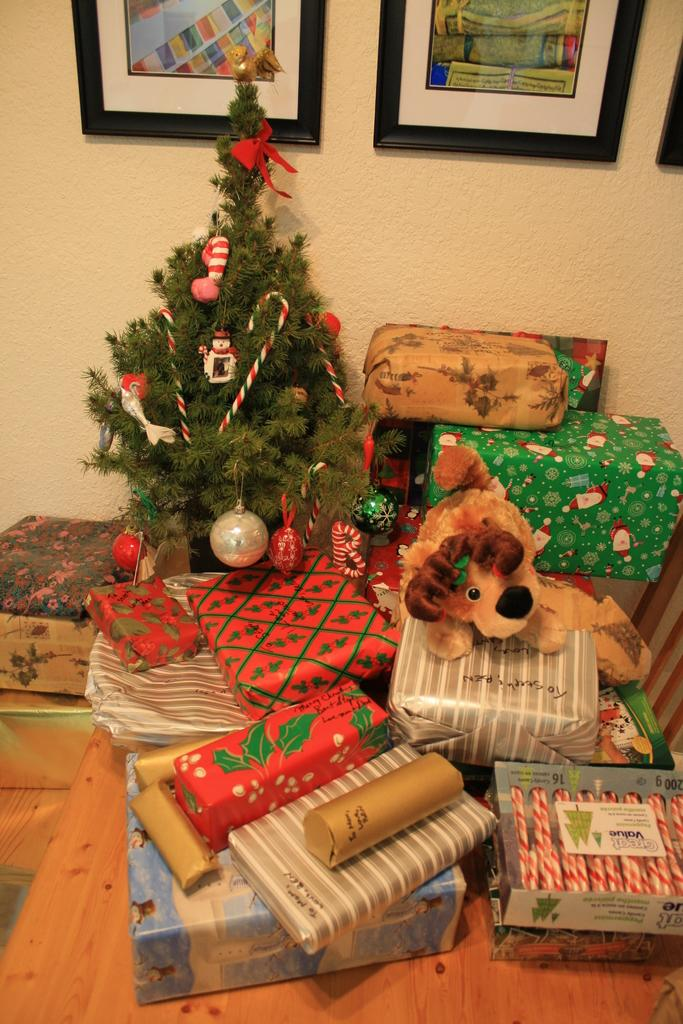What can be seen in abundance in the image? There are many gift packs in the image. Can you describe a specific toy in the image? There is a toy in brown and black color in the image. What seasonal decoration is present in the image? There is a Christmas tree in the image. What can be seen on the wall in the background of the image? There are frames on the wall in the background of the image. What position does the lunch take in the image? There is no mention of lunch in the image, so it cannot be determined what position it might take. 